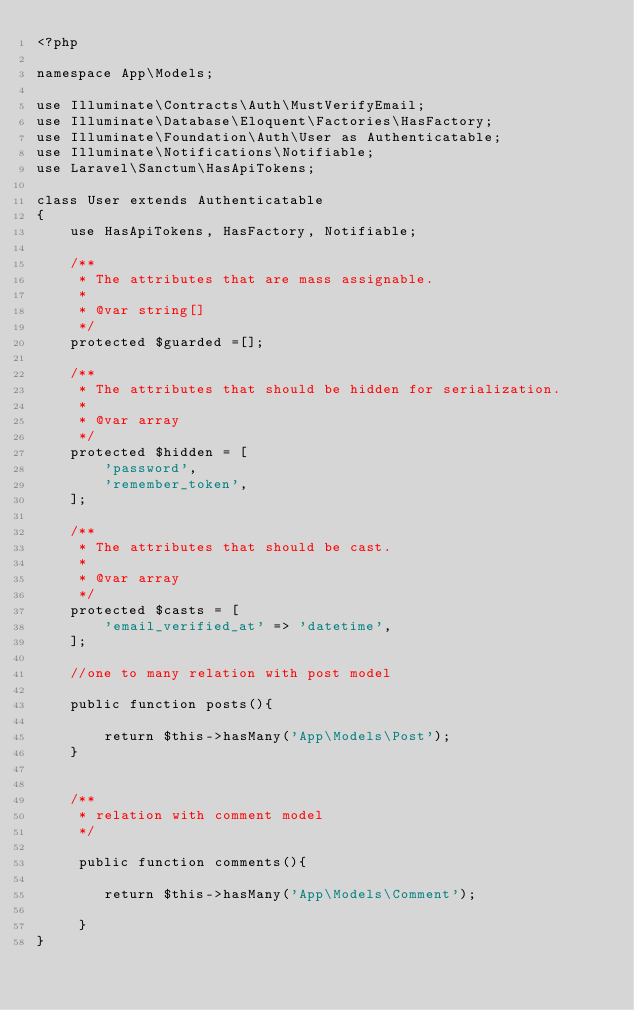<code> <loc_0><loc_0><loc_500><loc_500><_PHP_><?php

namespace App\Models;

use Illuminate\Contracts\Auth\MustVerifyEmail;
use Illuminate\Database\Eloquent\Factories\HasFactory;
use Illuminate\Foundation\Auth\User as Authenticatable;
use Illuminate\Notifications\Notifiable;
use Laravel\Sanctum\HasApiTokens;

class User extends Authenticatable
{
    use HasApiTokens, HasFactory, Notifiable;

    /**
     * The attributes that are mass assignable.
     *
     * @var string[]
     */
    protected $guarded =[];

    /**
     * The attributes that should be hidden for serialization.
     *
     * @var array
     */
    protected $hidden = [
        'password',
        'remember_token',
    ];

    /**
     * The attributes that should be cast.
     *
     * @var array
     */
    protected $casts = [
        'email_verified_at' => 'datetime',
    ];

    //one to many relation with post model

    public function posts(){

        return $this->hasMany('App\Models\Post');
    }


    /**
     * relation with comment model
     */

     public function comments(){

        return $this->hasMany('App\Models\Comment');

     }
}
</code> 